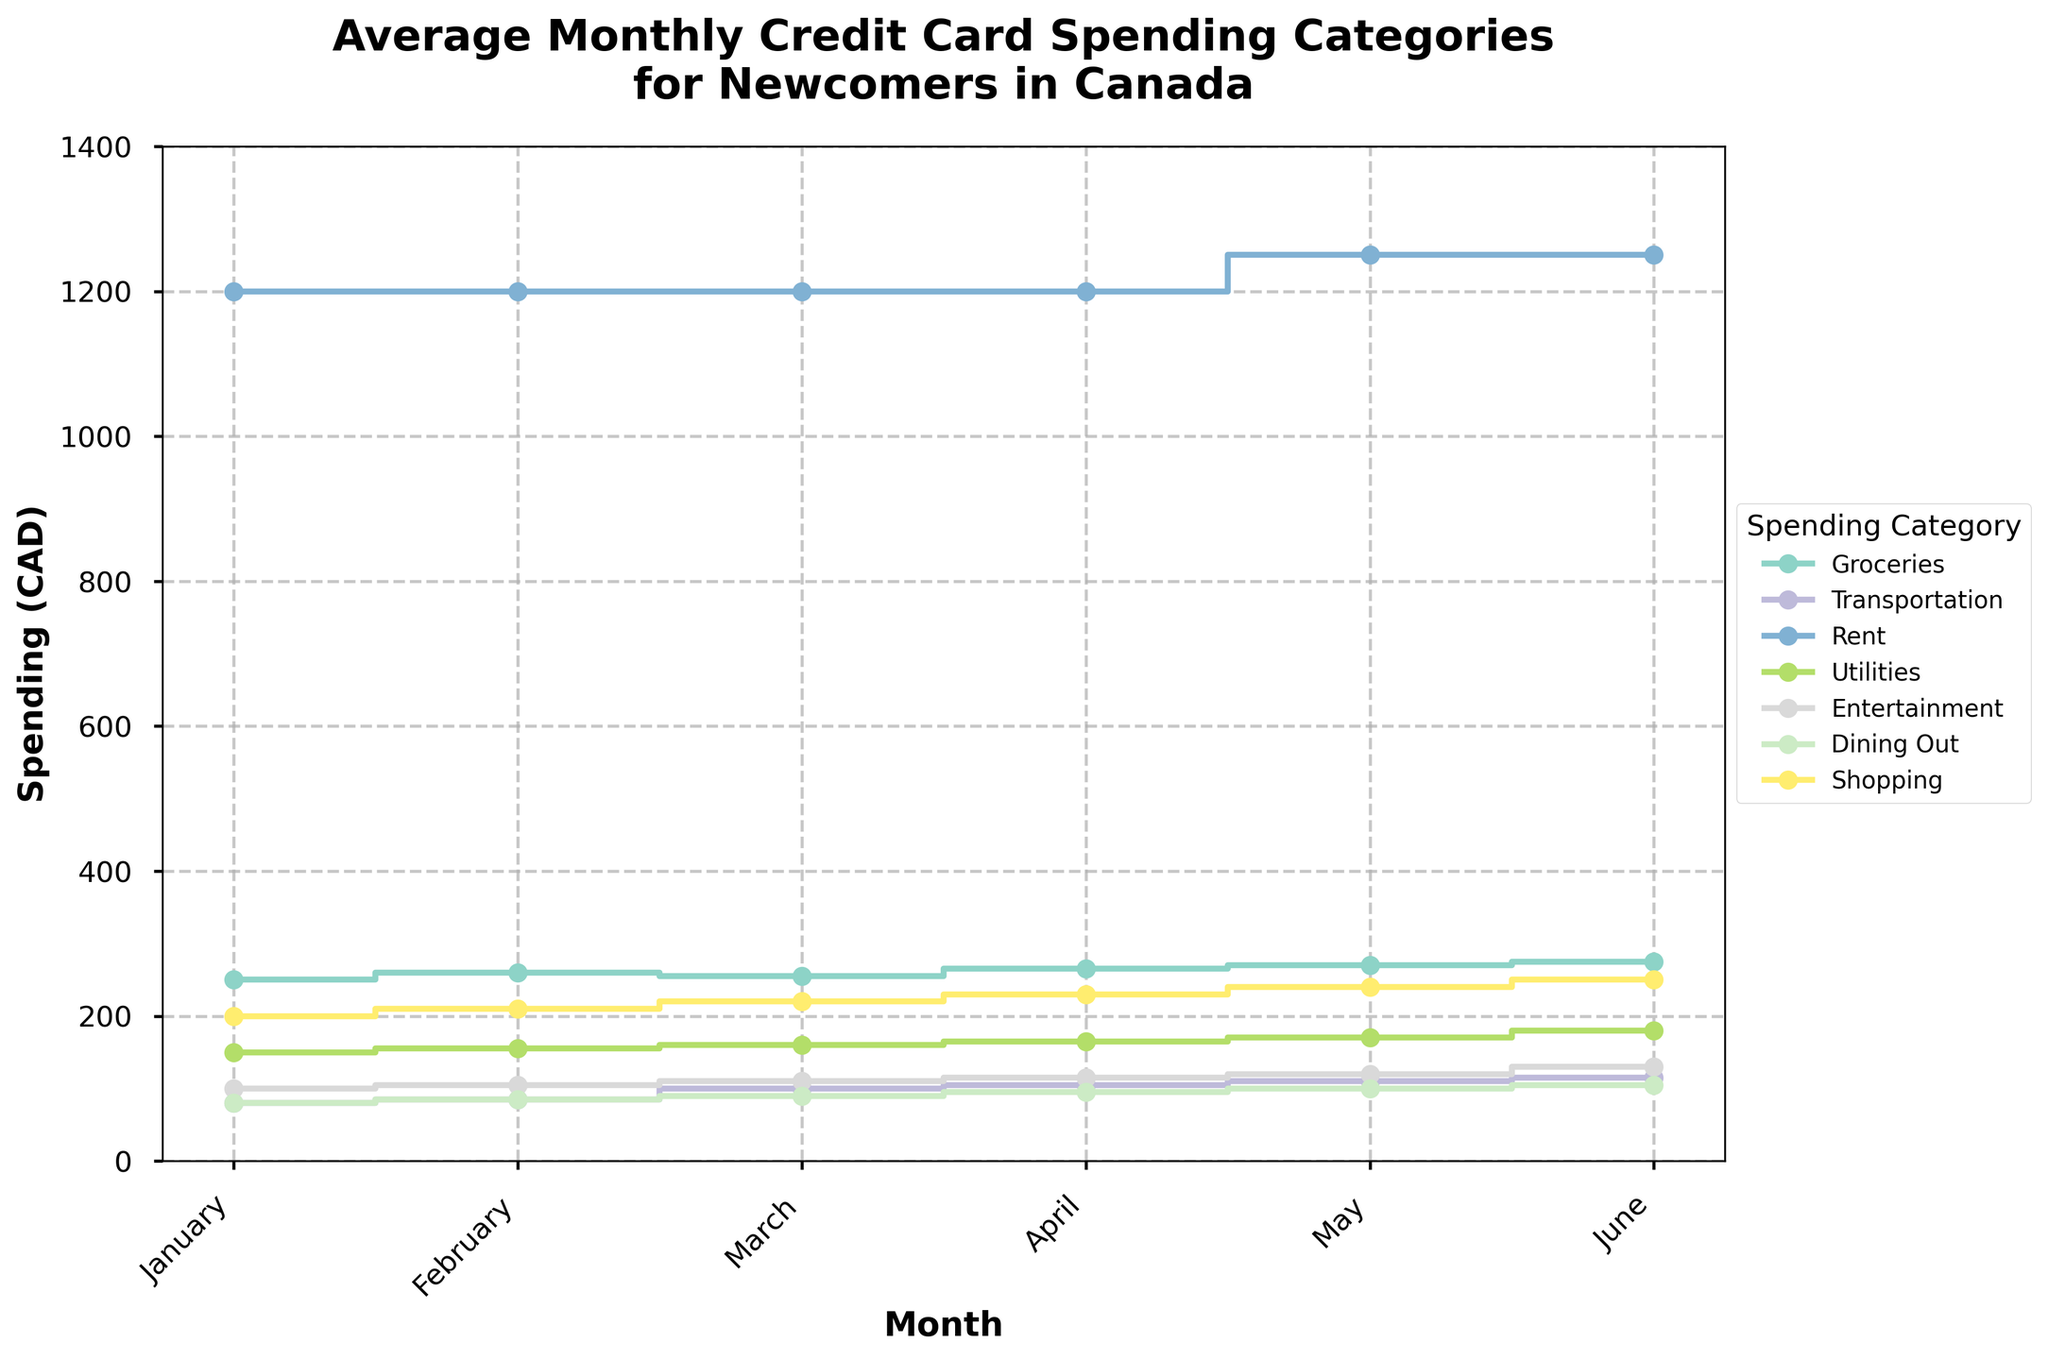How many spending categories are shown in the plot? Identify each distinct color/marker combination in the legend to count the number of categories present.
Answer: 7 What is the title of the figure? Look at the top part of the figure where the title is typically placed.
Answer: Average Monthly Credit Card Spending Categories\nfor Newcomers in Canada Which month shows the highest spending on Groceries? Observe the Groceries line (color-coded) and identify the month with the highest spending value.
Answer: June By how much did spending on Rent increase from April to May? Find the spending values for Rent in April and May and subtract the April value from the May value. 1250 - 1200
Answer: 50 Which category has the lowest average monthly spending over the six months? Calculate the average monthly spending for each category and compare them to find the lowest one.
Answer: Transportation How does the spending on Entertainment in March compare to that on Dining Out in the same month? Find the spending values for Entertainment and Dining Out in March and compare the two.
Answer: Entertainment is higher than Dining Out What is the total spending on Shopping and Groceries in February? Add the spending values for Shopping and Groceries in February. 210 + 260
Answer: 470 What is the total increase in spending on Utilities from January to June? Subtract the spending in January from that in June for Utilities. 180 - 150
Answer: 30 Which month has the highest average spending across all categories? Calculate the total spending for each month across all categories, divide by the number of categories, and find the highest average.
Answer: June Does any category show a constant spending value throughout all months? Review each category's line to see if any remain at a constant value across all months.
Answer: No 